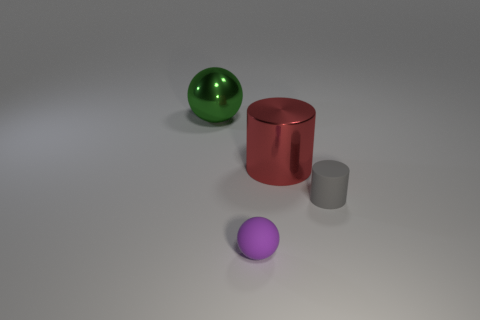Is the number of small gray rubber cylinders behind the small purple ball greater than the number of tiny gray cylinders that are to the left of the gray matte object?
Provide a succinct answer. Yes. What number of matte objects are small red cubes or cylinders?
Your answer should be compact. 1. Are there fewer purple rubber balls that are right of the small gray cylinder than small purple rubber things that are to the right of the big metallic ball?
Ensure brevity in your answer.  Yes. How many objects are either big green balls or objects that are left of the gray rubber cylinder?
Give a very brief answer. 3. What material is the purple ball that is the same size as the gray matte thing?
Give a very brief answer. Rubber. Do the big red thing and the gray thing have the same material?
Your response must be concise. No. There is a object that is both left of the large shiny cylinder and behind the tiny gray object; what color is it?
Your response must be concise. Green. What shape is the thing that is the same size as the green sphere?
Your response must be concise. Cylinder. How many other things are there of the same color as the shiny ball?
Provide a succinct answer. 0. What number of other objects are the same material as the big green thing?
Keep it short and to the point. 1. 